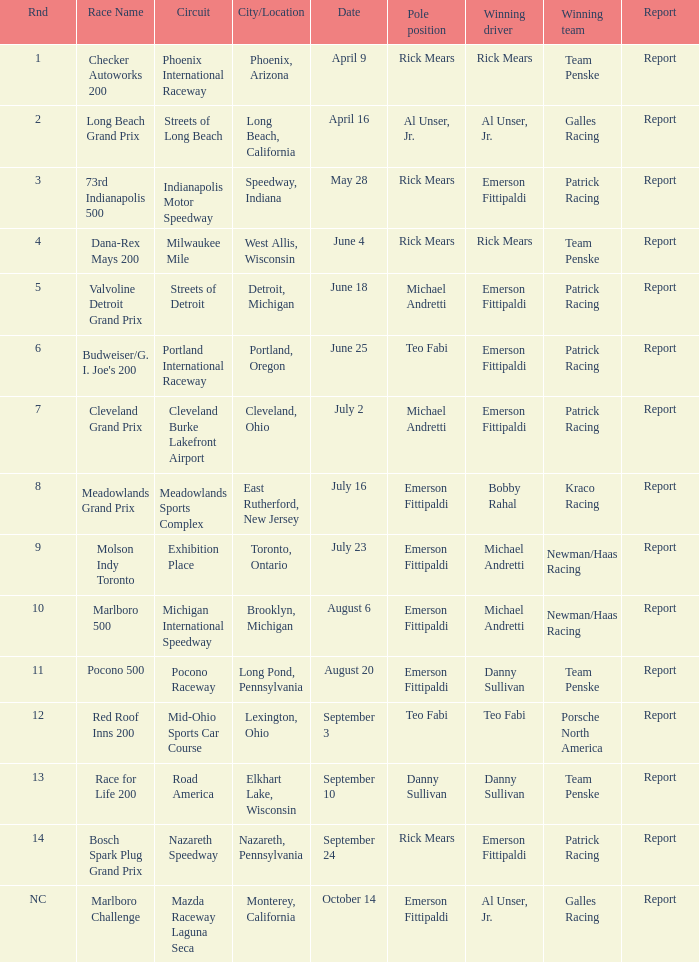What statement was there for the porsche north america? Report. 